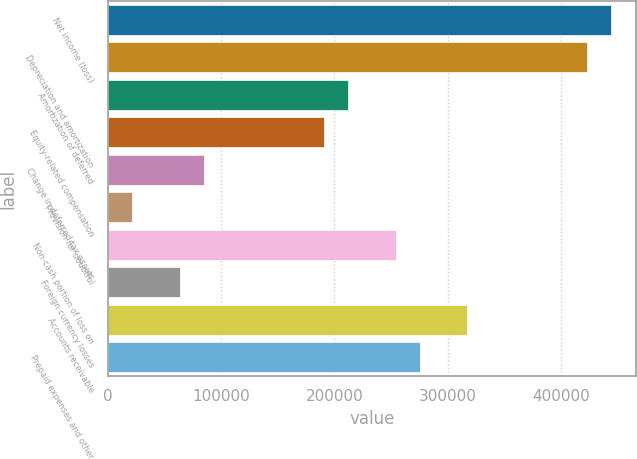Convert chart. <chart><loc_0><loc_0><loc_500><loc_500><bar_chart><fcel>Net income (loss)<fcel>Depreciation and amortization<fcel>Amortization of deferred<fcel>Equity-related compensation<fcel>Change in deferred tax assets<fcel>Provision for doubtful<fcel>Non-cash portion of loss on<fcel>Foreign currency losses<fcel>Accounts receivable<fcel>Prepaid expenses and other<nl><fcel>444538<fcel>423376<fcel>211753<fcel>190591<fcel>84779.2<fcel>21292.3<fcel>254078<fcel>63616.9<fcel>317564<fcel>275240<nl></chart> 